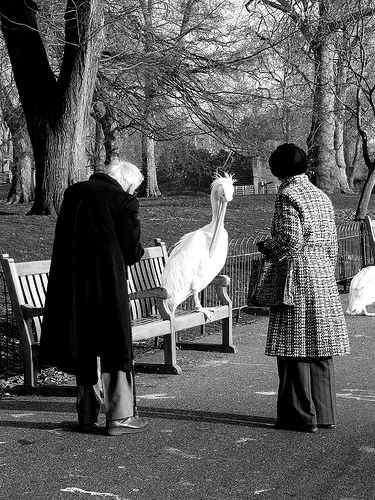Please provide the bounding box coordinate of the region this sentence describes: a bird on the bench. [0.45, 0.36, 0.61, 0.65] 